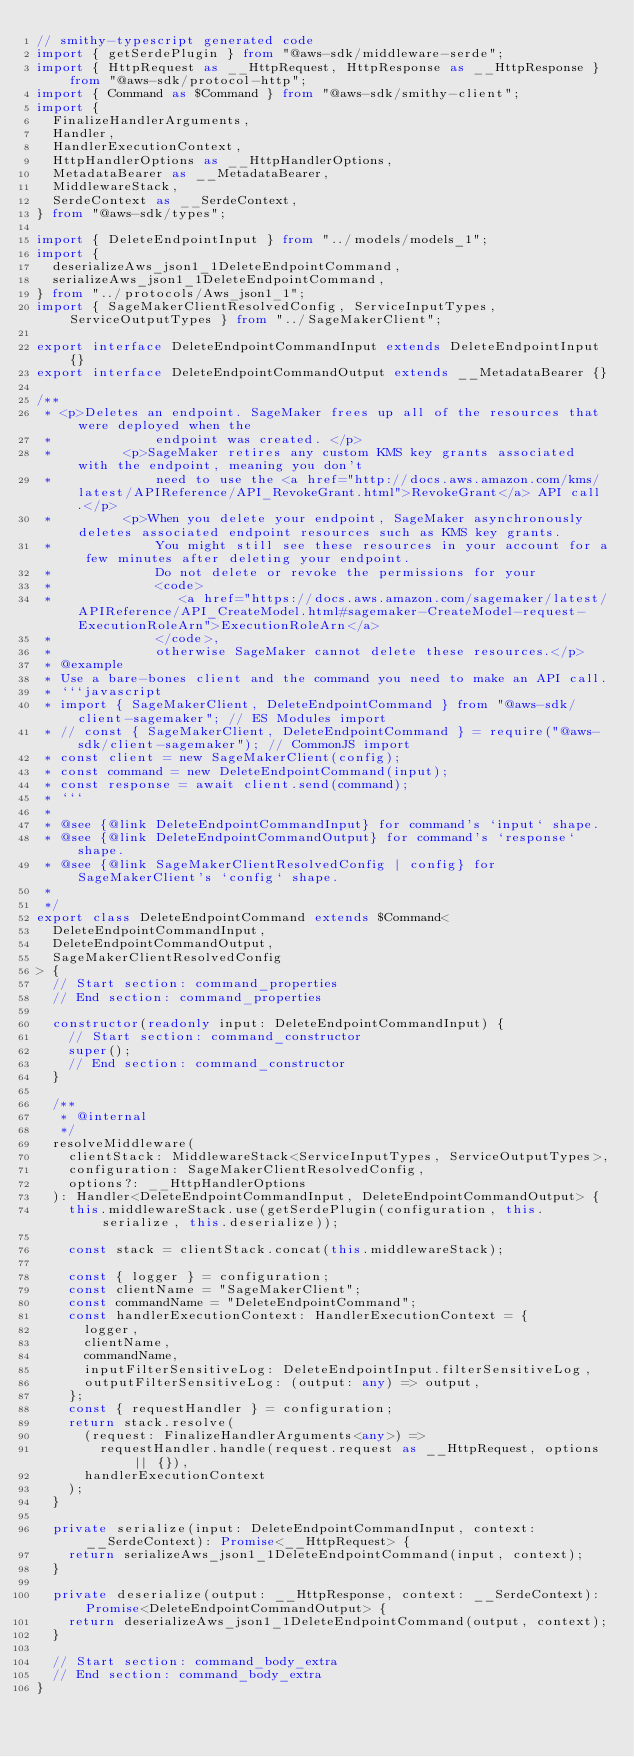<code> <loc_0><loc_0><loc_500><loc_500><_TypeScript_>// smithy-typescript generated code
import { getSerdePlugin } from "@aws-sdk/middleware-serde";
import { HttpRequest as __HttpRequest, HttpResponse as __HttpResponse } from "@aws-sdk/protocol-http";
import { Command as $Command } from "@aws-sdk/smithy-client";
import {
  FinalizeHandlerArguments,
  Handler,
  HandlerExecutionContext,
  HttpHandlerOptions as __HttpHandlerOptions,
  MetadataBearer as __MetadataBearer,
  MiddlewareStack,
  SerdeContext as __SerdeContext,
} from "@aws-sdk/types";

import { DeleteEndpointInput } from "../models/models_1";
import {
  deserializeAws_json1_1DeleteEndpointCommand,
  serializeAws_json1_1DeleteEndpointCommand,
} from "../protocols/Aws_json1_1";
import { SageMakerClientResolvedConfig, ServiceInputTypes, ServiceOutputTypes } from "../SageMakerClient";

export interface DeleteEndpointCommandInput extends DeleteEndpointInput {}
export interface DeleteEndpointCommandOutput extends __MetadataBearer {}

/**
 * <p>Deletes an endpoint. SageMaker frees up all of the resources that were deployed when the
 *             endpoint was created. </p>
 *         <p>SageMaker retires any custom KMS key grants associated with the endpoint, meaning you don't
 *             need to use the <a href="http://docs.aws.amazon.com/kms/latest/APIReference/API_RevokeGrant.html">RevokeGrant</a> API call.</p>
 *         <p>When you delete your endpoint, SageMaker asynchronously deletes associated endpoint resources such as KMS key grants.
 *             You might still see these resources in your account for a few minutes after deleting your endpoint.
 *             Do not delete or revoke the permissions for your
 *             <code>
 *                <a href="https://docs.aws.amazon.com/sagemaker/latest/APIReference/API_CreateModel.html#sagemaker-CreateModel-request-ExecutionRoleArn">ExecutionRoleArn</a>
 *             </code>,
 *             otherwise SageMaker cannot delete these resources.</p>
 * @example
 * Use a bare-bones client and the command you need to make an API call.
 * ```javascript
 * import { SageMakerClient, DeleteEndpointCommand } from "@aws-sdk/client-sagemaker"; // ES Modules import
 * // const { SageMakerClient, DeleteEndpointCommand } = require("@aws-sdk/client-sagemaker"); // CommonJS import
 * const client = new SageMakerClient(config);
 * const command = new DeleteEndpointCommand(input);
 * const response = await client.send(command);
 * ```
 *
 * @see {@link DeleteEndpointCommandInput} for command's `input` shape.
 * @see {@link DeleteEndpointCommandOutput} for command's `response` shape.
 * @see {@link SageMakerClientResolvedConfig | config} for SageMakerClient's `config` shape.
 *
 */
export class DeleteEndpointCommand extends $Command<
  DeleteEndpointCommandInput,
  DeleteEndpointCommandOutput,
  SageMakerClientResolvedConfig
> {
  // Start section: command_properties
  // End section: command_properties

  constructor(readonly input: DeleteEndpointCommandInput) {
    // Start section: command_constructor
    super();
    // End section: command_constructor
  }

  /**
   * @internal
   */
  resolveMiddleware(
    clientStack: MiddlewareStack<ServiceInputTypes, ServiceOutputTypes>,
    configuration: SageMakerClientResolvedConfig,
    options?: __HttpHandlerOptions
  ): Handler<DeleteEndpointCommandInput, DeleteEndpointCommandOutput> {
    this.middlewareStack.use(getSerdePlugin(configuration, this.serialize, this.deserialize));

    const stack = clientStack.concat(this.middlewareStack);

    const { logger } = configuration;
    const clientName = "SageMakerClient";
    const commandName = "DeleteEndpointCommand";
    const handlerExecutionContext: HandlerExecutionContext = {
      logger,
      clientName,
      commandName,
      inputFilterSensitiveLog: DeleteEndpointInput.filterSensitiveLog,
      outputFilterSensitiveLog: (output: any) => output,
    };
    const { requestHandler } = configuration;
    return stack.resolve(
      (request: FinalizeHandlerArguments<any>) =>
        requestHandler.handle(request.request as __HttpRequest, options || {}),
      handlerExecutionContext
    );
  }

  private serialize(input: DeleteEndpointCommandInput, context: __SerdeContext): Promise<__HttpRequest> {
    return serializeAws_json1_1DeleteEndpointCommand(input, context);
  }

  private deserialize(output: __HttpResponse, context: __SerdeContext): Promise<DeleteEndpointCommandOutput> {
    return deserializeAws_json1_1DeleteEndpointCommand(output, context);
  }

  // Start section: command_body_extra
  // End section: command_body_extra
}
</code> 